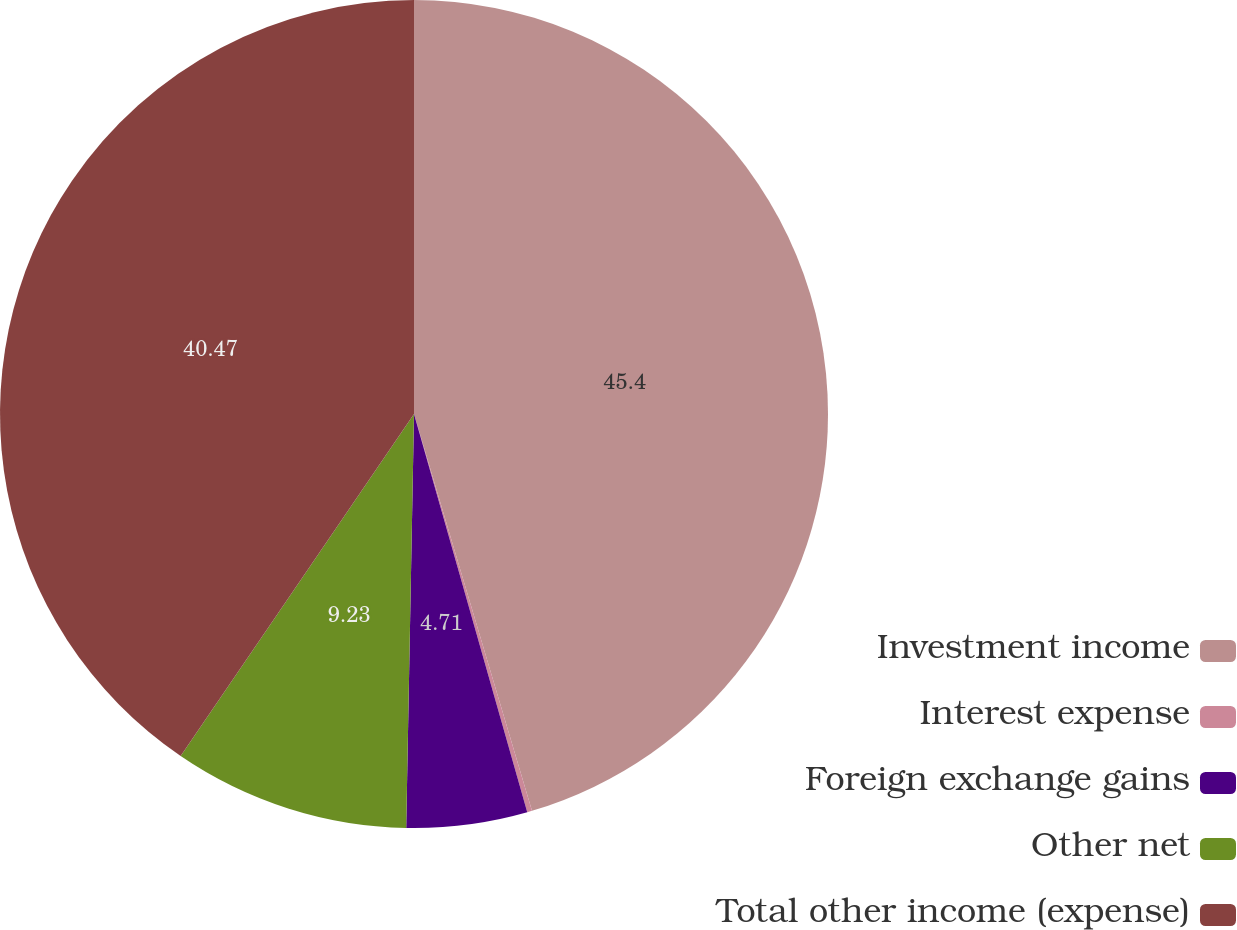Convert chart. <chart><loc_0><loc_0><loc_500><loc_500><pie_chart><fcel>Investment income<fcel>Interest expense<fcel>Foreign exchange gains<fcel>Other net<fcel>Total other income (expense)<nl><fcel>45.4%<fcel>0.19%<fcel>4.71%<fcel>9.23%<fcel>40.47%<nl></chart> 